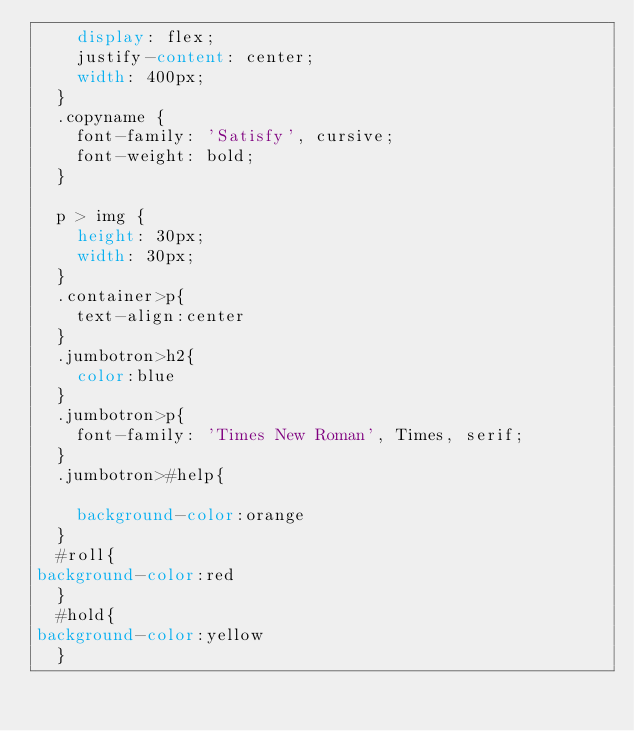<code> <loc_0><loc_0><loc_500><loc_500><_CSS_>    display: flex;
    justify-content: center;
    width: 400px;
  }
  .copyname {
    font-family: 'Satisfy', cursive;
    font-weight: bold;
  }
  
  p > img {
    height: 30px;
    width: 30px;
  }
  .container>p{
    text-align:center
  }
  .jumbotron>h2{
    color:blue
  }
  .jumbotron>p{
    font-family: 'Times New Roman', Times, serif;
  }
  .jumbotron>#help{
    
    background-color:orange
  }
  #roll{
background-color:red
  }
  #hold{
background-color:yellow
  }
    
  
  </code> 